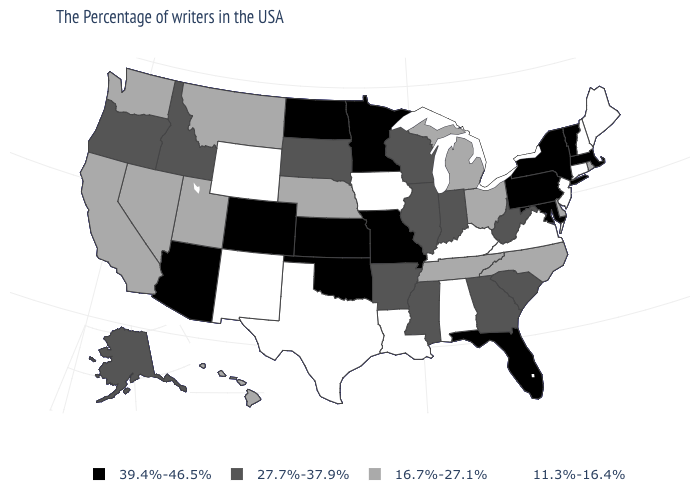Among the states that border South Dakota , which have the lowest value?
Quick response, please. Iowa, Wyoming. What is the lowest value in the USA?
Give a very brief answer. 11.3%-16.4%. What is the value of California?
Quick response, please. 16.7%-27.1%. What is the value of Montana?
Quick response, please. 16.7%-27.1%. What is the highest value in the USA?
Quick response, please. 39.4%-46.5%. What is the lowest value in states that border Minnesota?
Short answer required. 11.3%-16.4%. Does South Carolina have the lowest value in the South?
Keep it brief. No. Does Washington have the highest value in the West?
Be succinct. No. What is the value of Delaware?
Concise answer only. 16.7%-27.1%. Which states hav the highest value in the South?
Short answer required. Maryland, Florida, Oklahoma. What is the lowest value in states that border Minnesota?
Quick response, please. 11.3%-16.4%. What is the value of Idaho?
Keep it brief. 27.7%-37.9%. Among the states that border Massachusetts , which have the lowest value?
Be succinct. New Hampshire, Connecticut. Which states have the lowest value in the USA?
Answer briefly. Maine, New Hampshire, Connecticut, New Jersey, Virginia, Kentucky, Alabama, Louisiana, Iowa, Texas, Wyoming, New Mexico. What is the highest value in the Northeast ?
Be succinct. 39.4%-46.5%. 